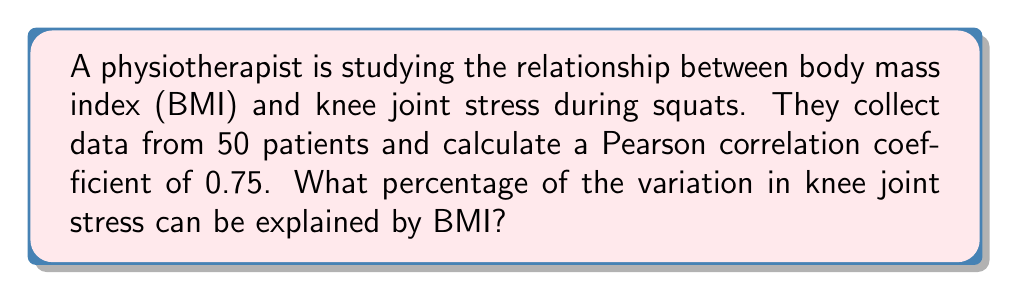Teach me how to tackle this problem. To determine the percentage of variation in knee joint stress that can be explained by BMI, we need to calculate the coefficient of determination, also known as R-squared (R²).

Step 1: Recall that the Pearson correlation coefficient (r) is 0.75.

Step 2: Calculate R² by squaring the correlation coefficient:
$$R^2 = r^2 = (0.75)^2 = 0.5625$$

Step 3: Convert R² to a percentage:
$$0.5625 \times 100\% = 56.25\%$$

This means that 56.25% of the variation in knee joint stress can be explained by BMI.

The remaining 43.75% of the variation is due to other factors not accounted for in this correlation, such as individual biomechanics, muscle strength, or technique variations.
Answer: 56.25% 